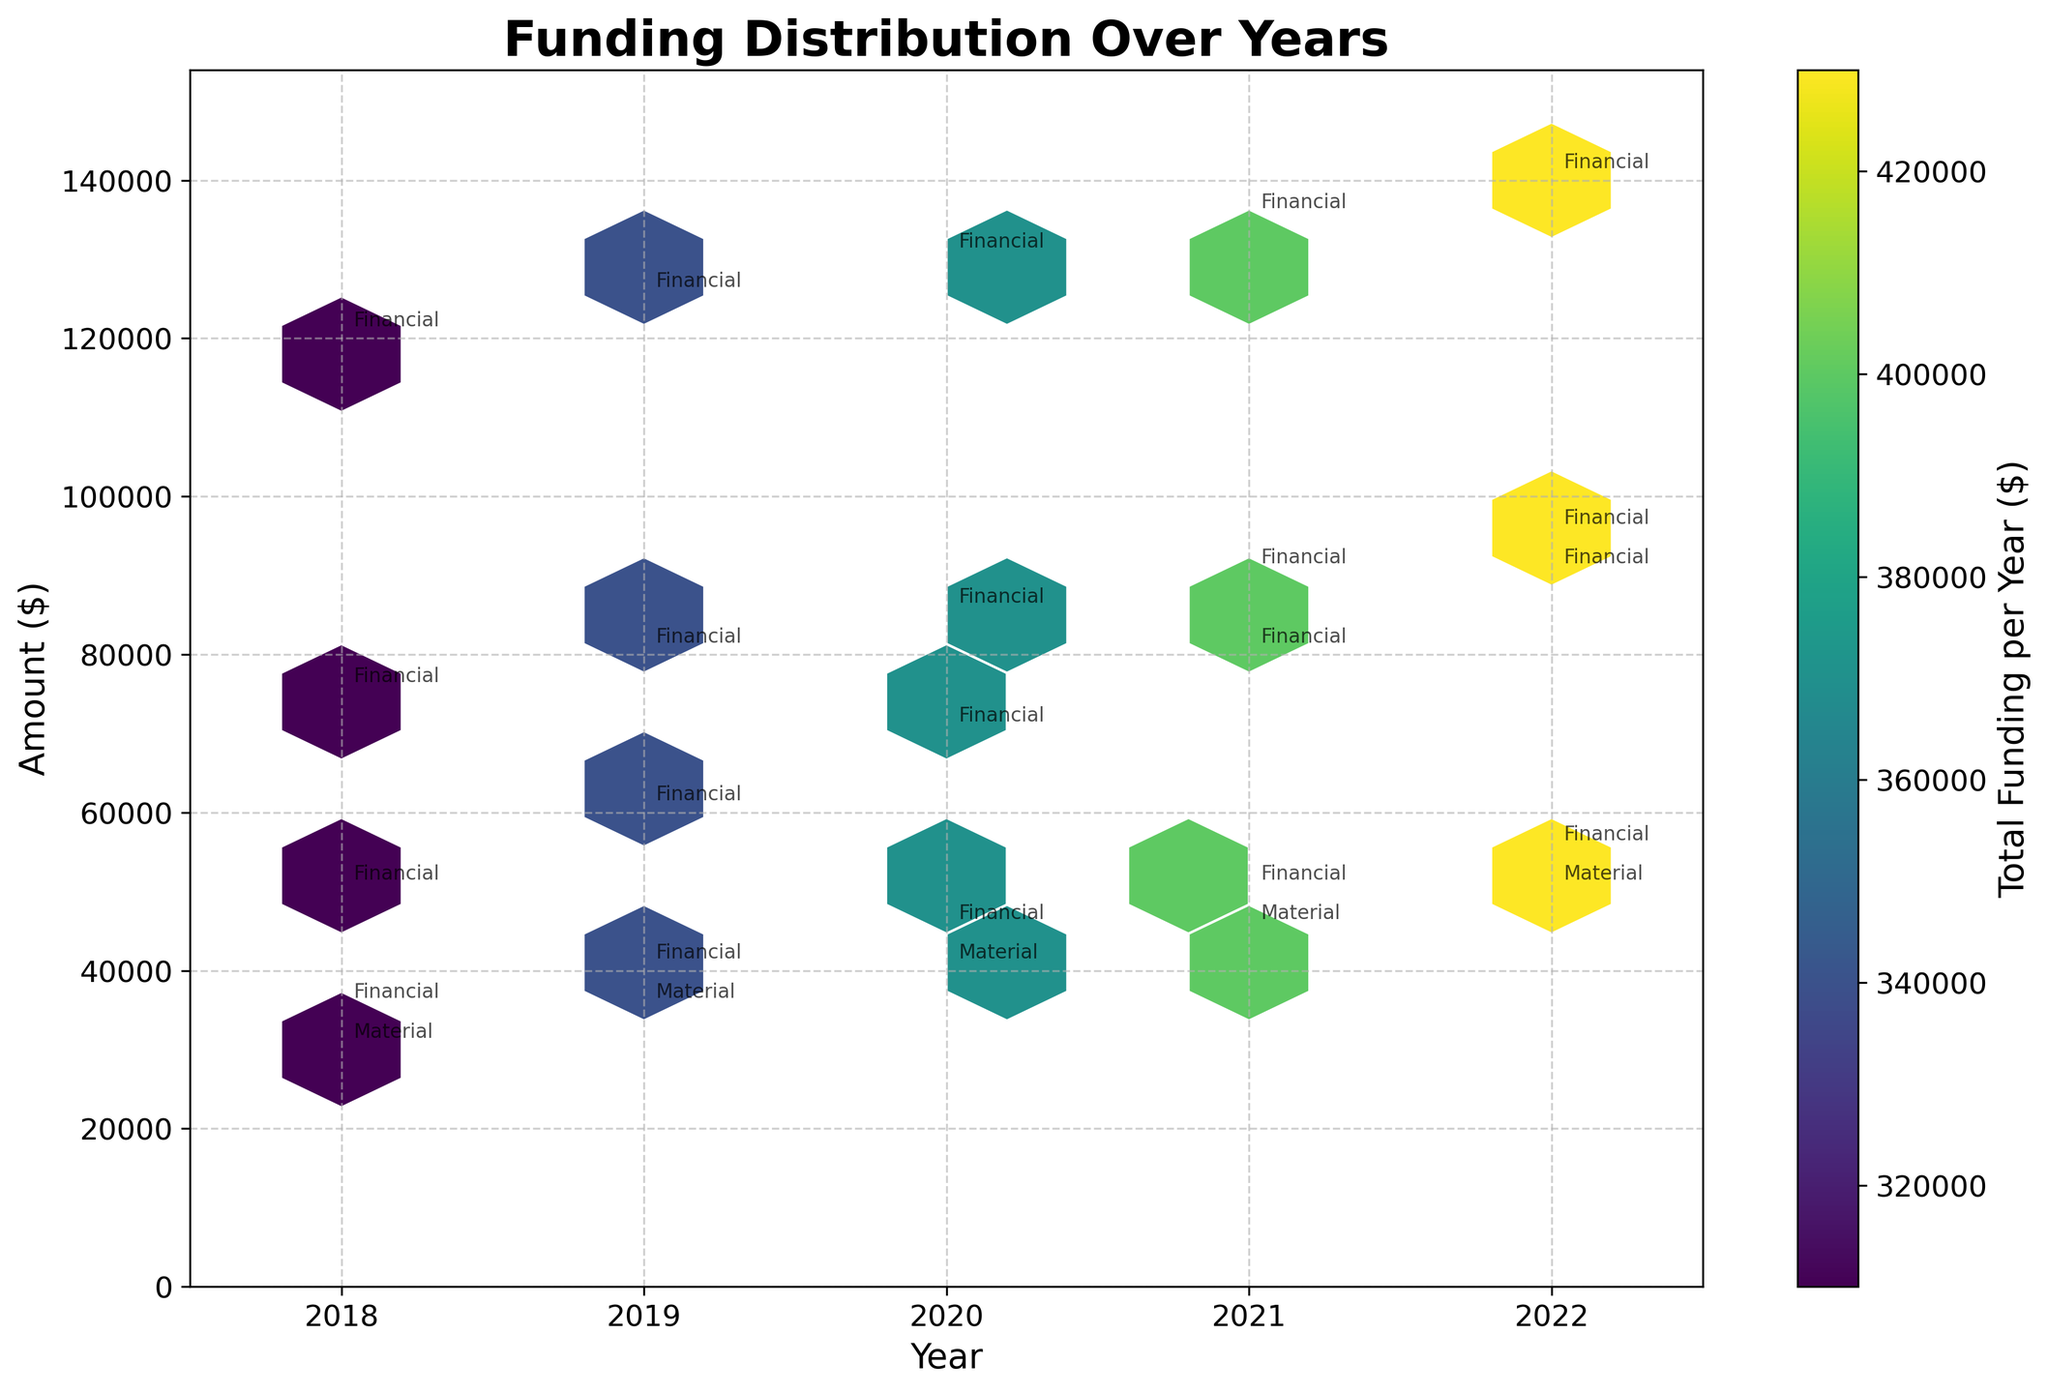what is the title of the plot? The title of the plot is located at the top of the figure and is typically displayed in a larger and bold font size.
Answer: "Funding Distribution Over Years" What are the axes titles? The axes titles are located alongside the respective axes. The x-axis title is typically displayed horizontally below the axis, and the y-axis title is displayed vertically alongside the axis.
Answer: "Year" (x-axis) and "Amount ($)" (y-axis) What is the color scale representing in this hexbin plot? The color scale in a hexbin plot usually represents an aggregated value for the bins, given the context, it should represent the total funding amount per year.
Answer: "Total Funding per Year ($)" What support type is annotated at the $40,000 funding level in 2020? Look at the annotations around the $40,000 funding level on the y-axis in the year 2020 on the x-axis. Identify the support type label close to this point.
Answer: "Material" How does the total funding amount change from 2018 to 2022? Observe the color intensity in the hexbin plot over time. The color gets denser as the total funding amount increases, so you can compare the colors from 2018 to 2022.
Answer: It increases Which year has the highest amount of financial support from Individual Donors? Identify the annotations labeled "Individual Donors" and then check the corresponding years and funding amounts to determine the highest.
Answer: "2022" How does the frequency of financial support compare to material support over the years? Look at the number of points categorized as "Financial" and "Material" by their annotations and compare their presence across different years.
Answer: Financial support appears more frequently What is the general trend in corporate donations over the years? Look at the funding amounts annotated as corporate donations (e.g., Amazon, Microsoft, Google) and observe their values across different years to identify any trends.
Answer: Increasing In which year do we see the largest hexbin representing total funding? Examine the color intensity and size of hexbins representing total funding across the years. The largest and densest hexbin indicates the year with the highest total funding.
Answer: "2022" How many unique funding sources are shown in the plot? Count the unique annotations referring to different funding sources across the years. These include names like "United Way", "Local Government Grant", etc.
Answer: "5" 